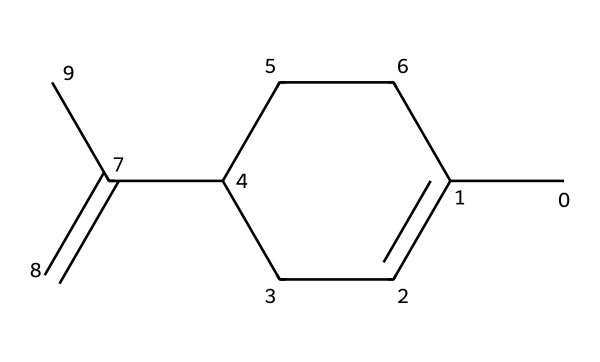What is the molecular formula of limonene? To find the molecular formula, we count the number of carbon (C) and hydrogen (H) atoms in the structure indicated by the SMILES. The structure CC1=CCC(CC1)C(=C)C contains 10 carbon atoms and 16 hydrogen atoms. Thus, the molecular formula is C10H16.
Answer: C10H16 How many rings are present in the structure? By analyzing the SMILES representation, we observe that the "C1" indicates the start and end of a carbon ring. There is only one cycle formed since it returns to this carbon, therefore, there is one ring.
Answer: 1 What type of solvent is limonene classified as? Limonene is primarily known as a terpenes and represents a type of solvent that is non-polar and derived from citrus fruits. Thus, it is classified as a citrus-scented solvent, known for its cleaning properties.
Answer: terpenes How many double bonds are in the structure? The structure shows two C=C double bonds (one in the ring and another on the side chain), indicating that there are two double bonds present in the molecule.
Answer: 2 Is limonene a polar or non-polar solvent? The overall structure, with its compact hydrocarbon framework and absence of electronegative atoms, suggests that limonene is non-polar. Hence, it functions well as a solvent for non-polar substances.
Answer: non-polar What is the primary use of limonene in cleaning products? Limonene is primarily used in cleaning products for its pleasant citrus scent and its ability to dissolve oils and greases due to its non-polar nature, enhancing the overall cleaning effectiveness.
Answer: solvent 